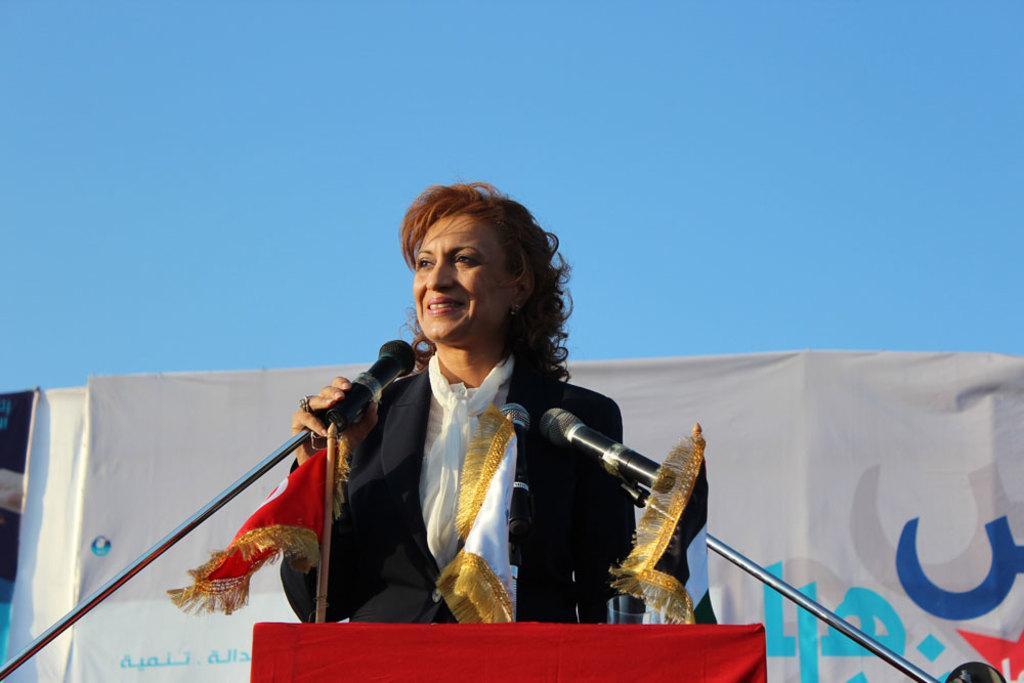In one or two sentences, can you explain what this image depicts? In this image there is a woman who is standing in front of the podium by holding the mic. On the podium there are two mics and two flags. In the background there is a banner. At the top there is the sky. 